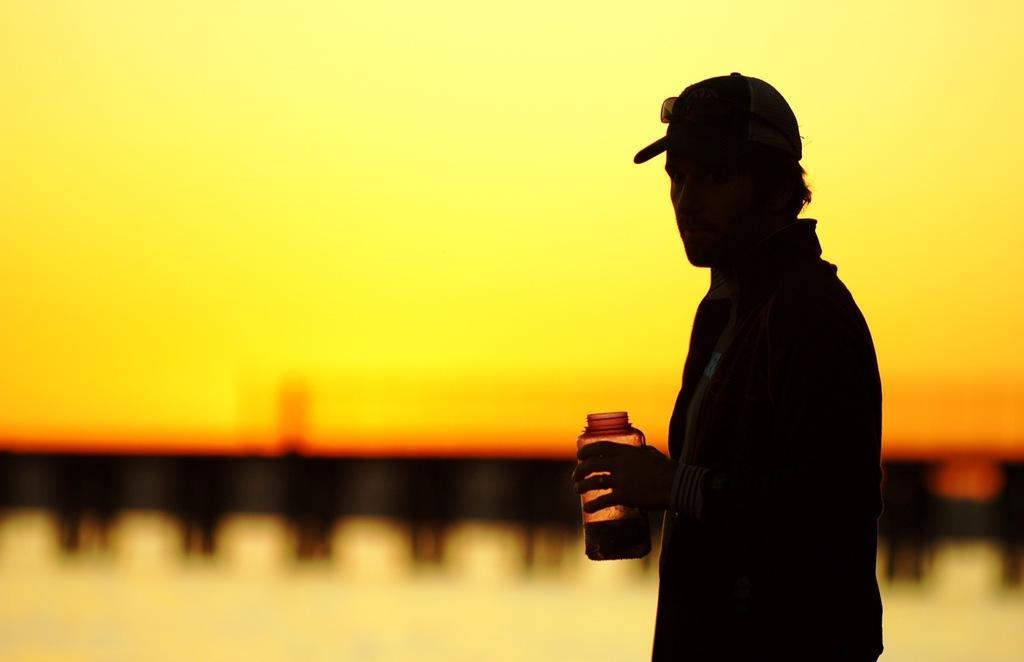Could you give a brief overview of what you see in this image? In this image we can see a person wearing jacket, also wearing cap and goggles holding some bottle in his hands and in the background image is blur. 